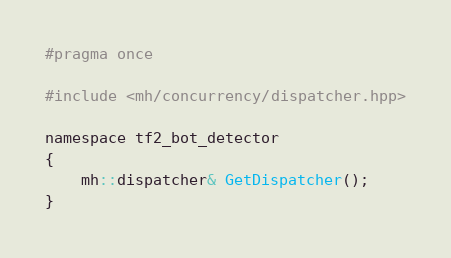Convert code to text. <code><loc_0><loc_0><loc_500><loc_500><_C_>#pragma once

#include <mh/concurrency/dispatcher.hpp>

namespace tf2_bot_detector
{
	mh::dispatcher& GetDispatcher();
}
</code> 